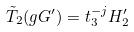<formula> <loc_0><loc_0><loc_500><loc_500>\tilde { T } _ { 2 } ( g G ^ { \prime } ) = t _ { 3 } ^ { - j } H _ { 2 } ^ { \prime }</formula> 